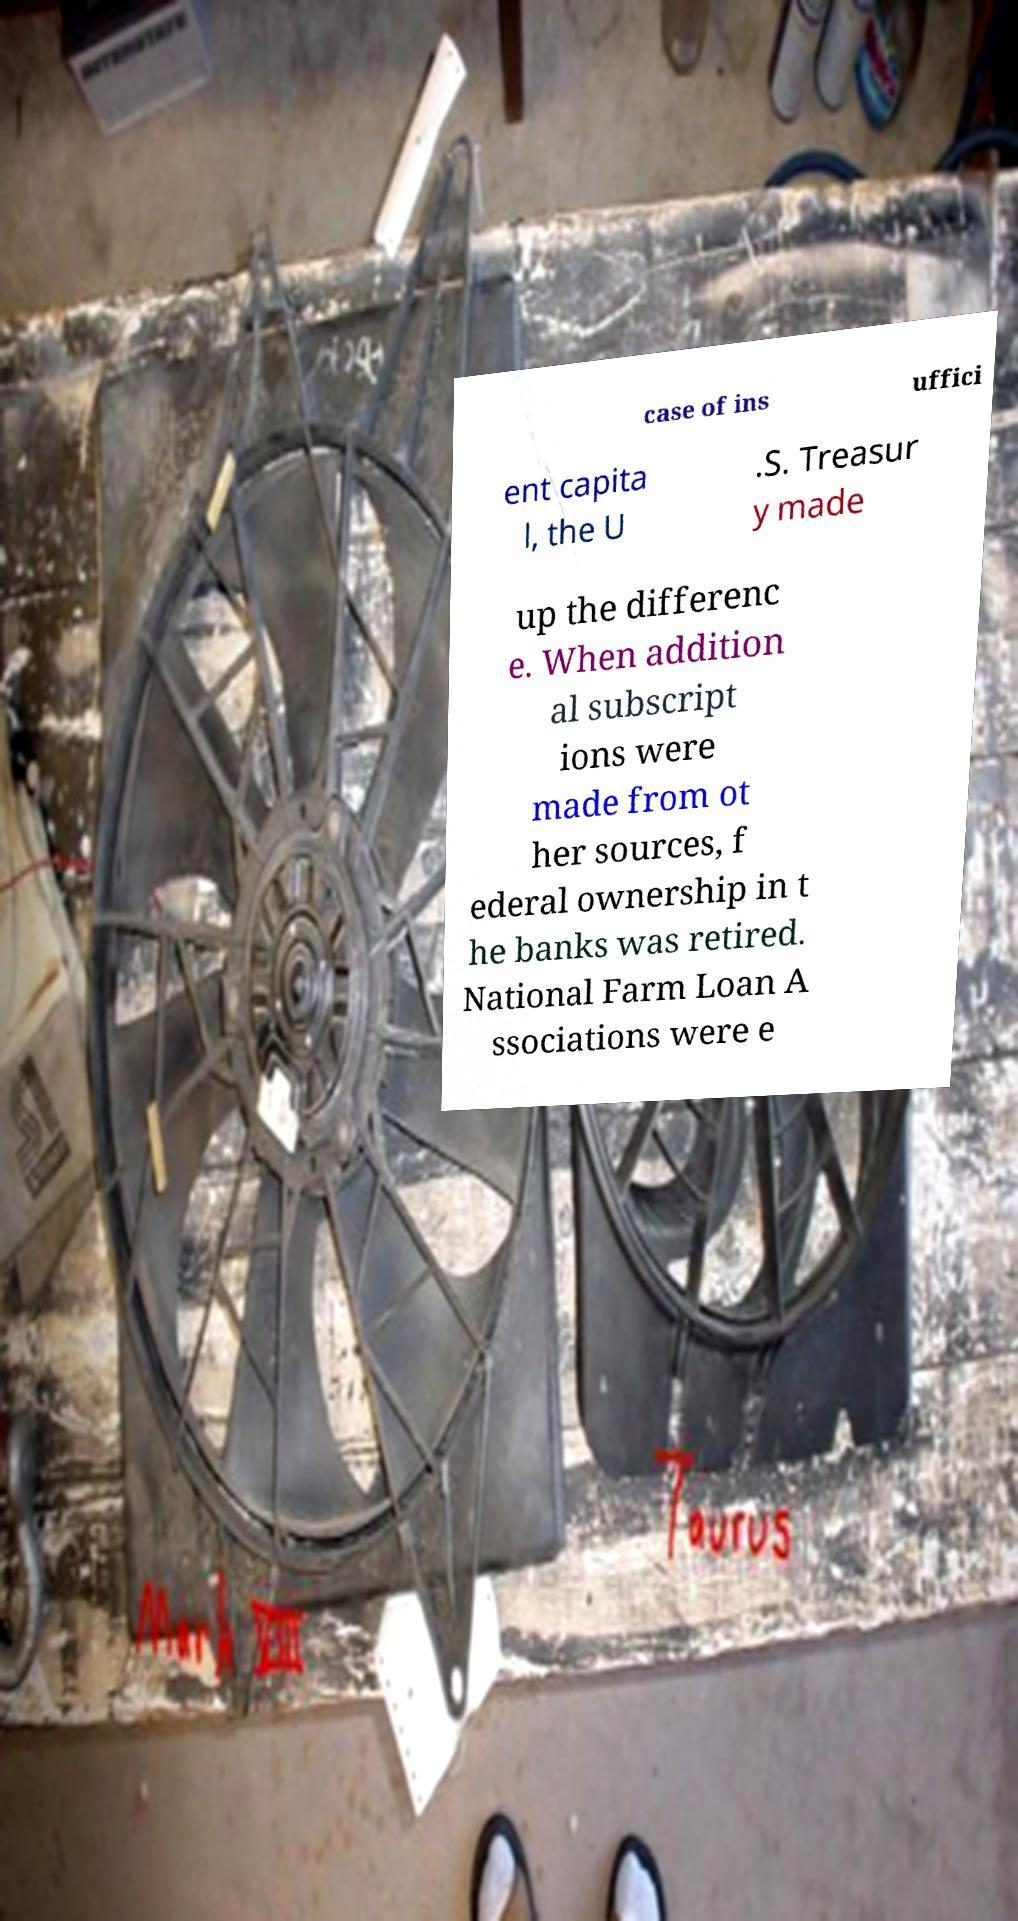Please read and relay the text visible in this image. What does it say? case of ins uffici ent capita l, the U .S. Treasur y made up the differenc e. When addition al subscript ions were made from ot her sources, f ederal ownership in t he banks was retired. National Farm Loan A ssociations were e 